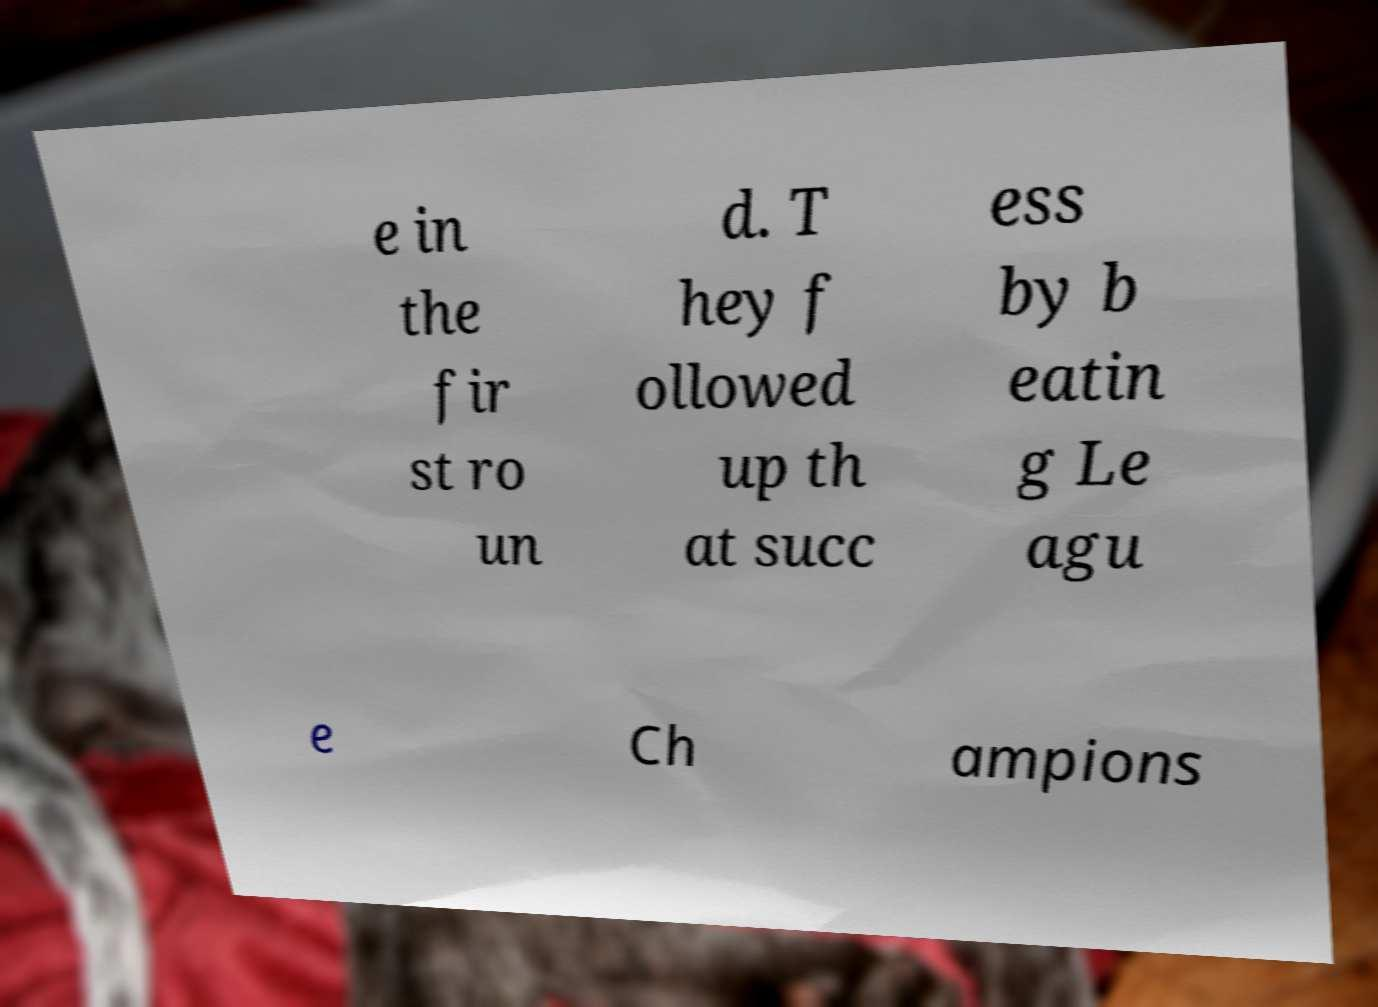I need the written content from this picture converted into text. Can you do that? e in the fir st ro un d. T hey f ollowed up th at succ ess by b eatin g Le agu e Ch ampions 